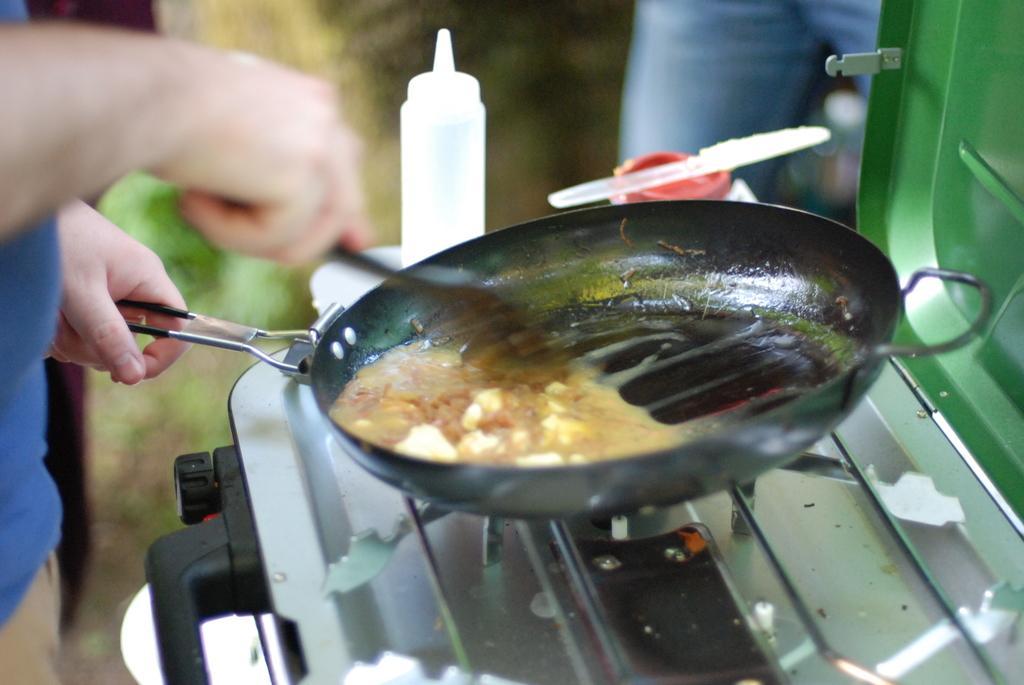Could you give a brief overview of what you see in this image? On the left corner we can see a person standing, holding some objects and cooking some food item in the black color utensil. On the right we can see the stove, bottle and some other objects. 